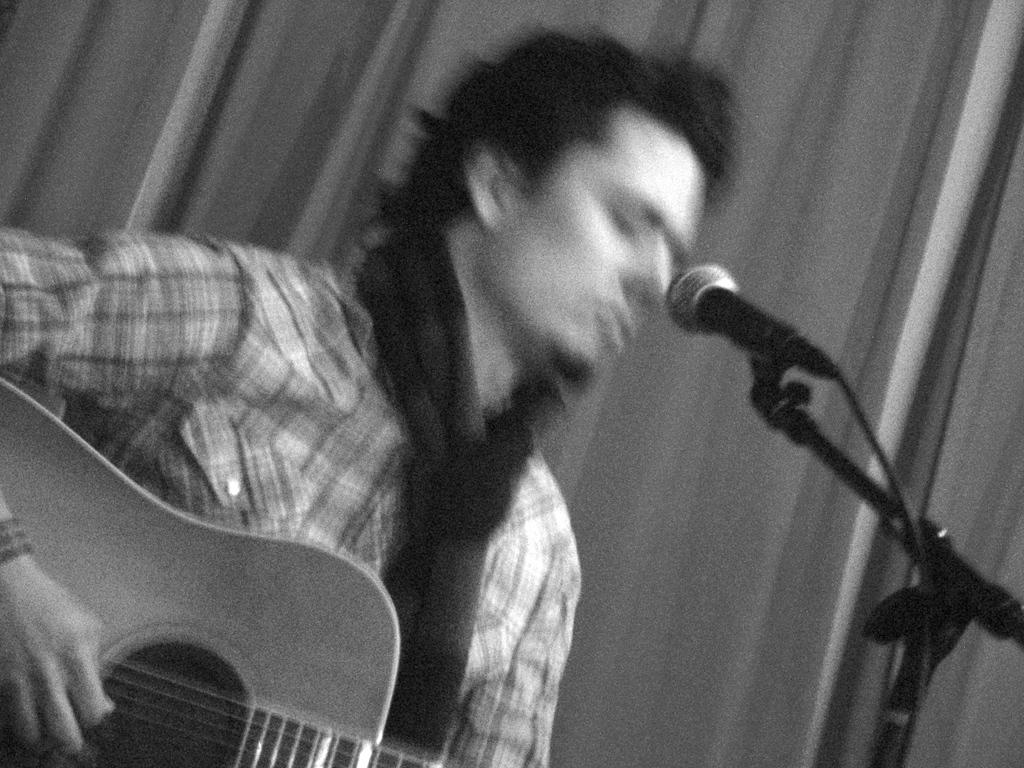What is the person in the room doing? The person is playing the guitar and singing a song. How is the person's voice being amplified in the room? The person is standing in front of a microphone. What is the person wearing in the image? The person is wearing a shirt. What piece of furniture is present in the room? There is a black stool in the room. How many cattle are present in the room? There are no cattle present in the room; the image only features a person playing the guitar and singing. 